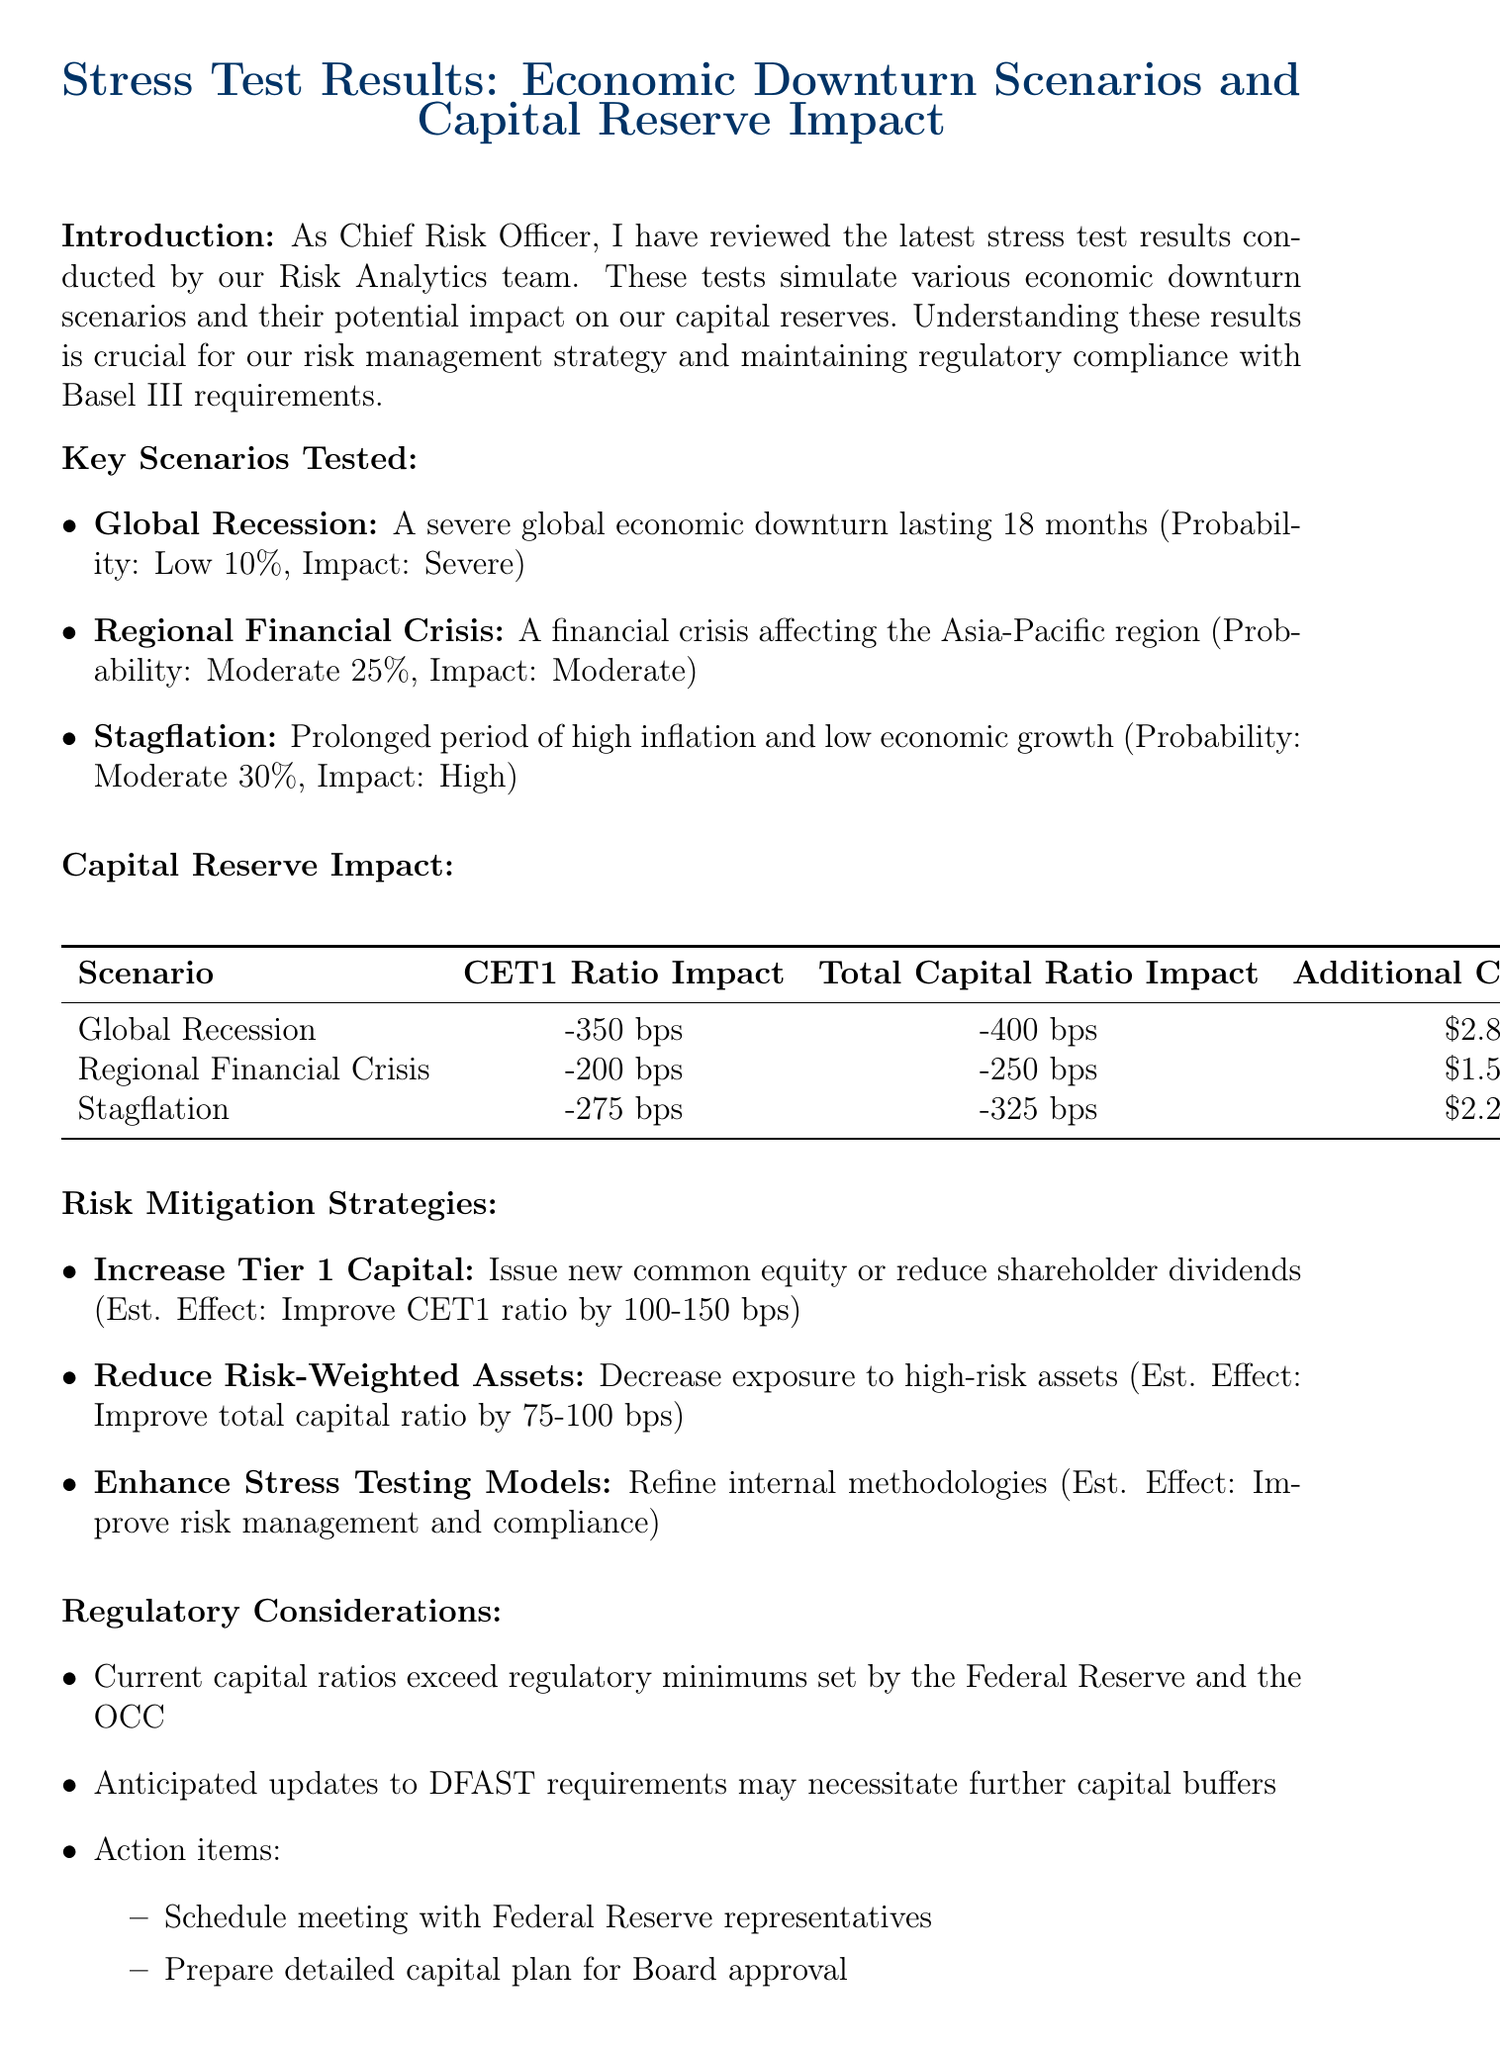What is the title of the memo? The title of the memo is provided at the beginning of the document, summarizing the content focus on stress test results and capital reserve impact.
Answer: Stress Test Results: Economic Downturn Scenarios and Capital Reserve Impact What is the probability of the Global Recession scenario? The document explicitly states the probability associated with the Global Recession scenario as part of the key scenarios tested.
Answer: Low (10%) What additional capital is required for the Regional Financial Crisis scenario? The document lists the additional capital required for each scenario, including the Regional Financial Crisis.
Answer: $1.5 billion What is the estimated effect of increasing Tier 1 Capital? The document details the anticipated improvement from various risk mitigation strategies, including increasing Tier 1 Capital.
Answer: Improve CET1 ratio by 100-150 basis points What are the next steps recommended in the conclusion? The conclusion section summarizes the actions suggested following the stress test results, emphasizing the need for further discussions.
Answer: Convene an executive committee meeting What is the potential impact of the Stagflation scenario on the CET1 ratio? The document provides specific impacts on the CET1 ratio for each tested scenario, including Stagflation.
Answer: -275 basis points What action item involves the Federal Reserve? The regulatory considerations section mentions specific actions to be taken, including a meeting with a regulatory agency.
Answer: Schedule meeting with Federal Reserve representatives What ongoing regulatory requirement does the document mention? The introduction highlights compliance with the Basel III requirements as a critical aspect of the stress testing process.
Answer: Basel III requirements What is the impact on total capital ratio for the Global Recession scenario? The document specifies the total capital ratio impact for the Global Recession scenario in the capital reserve impact section.
Answer: -400 basis points 